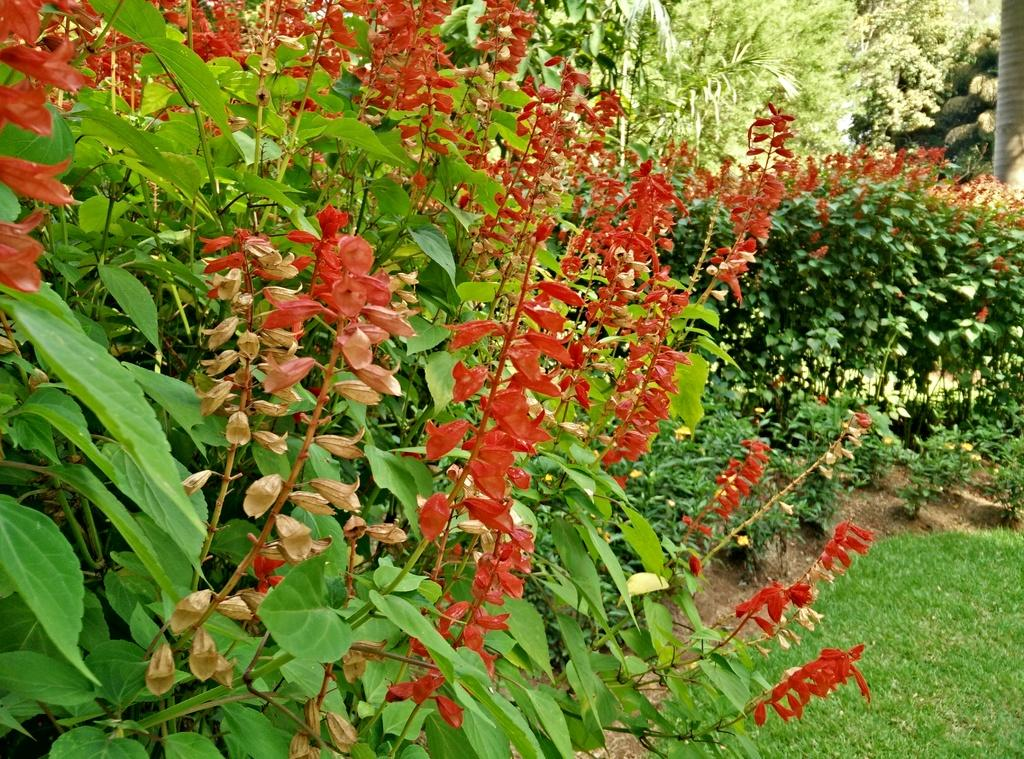What type of plants can be seen in the image? There are plants with flowers on the ground. What type of vegetation is visible on the ground? There is grass visible in the image. What can be seen in the background of the image? There are trees in the background of the image. What type of payment is required to access the health benefits of the plants in the image? There is no payment or health benefits associated with the plants in the image; it is a simple depiction of plants and their surroundings. 